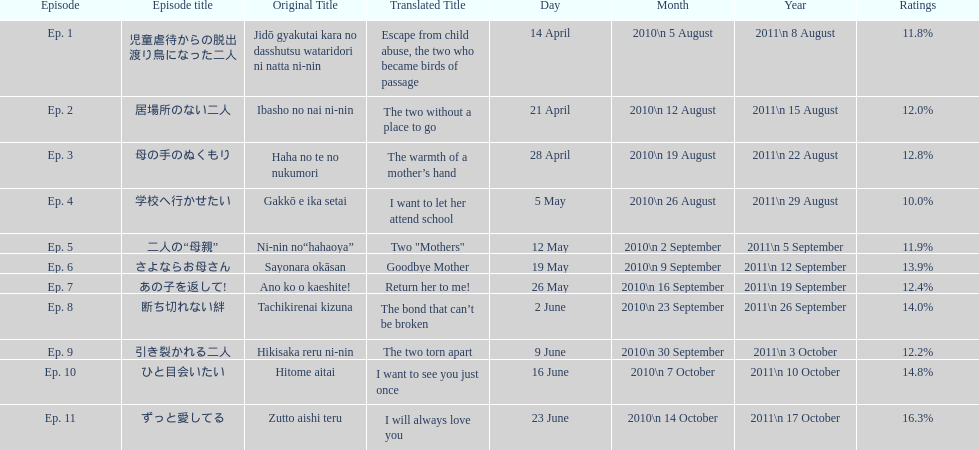How many episodes had a consecutive rating over 11%? 7. 